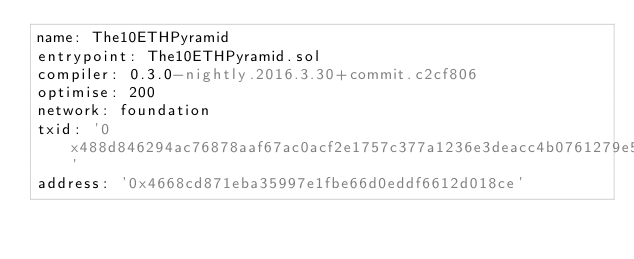Convert code to text. <code><loc_0><loc_0><loc_500><loc_500><_YAML_>name: The10ETHPyramid
entrypoint: The10ETHPyramid.sol
compiler: 0.3.0-nightly.2016.3.30+commit.c2cf806
optimise: 200
network: foundation
txid: '0x488d846294ac76878aaf67ac0acf2e1757c377a1236e3deacc4b0761279e533d'
address: '0x4668cd871eba35997e1fbe66d0eddf6612d018ce'
</code> 